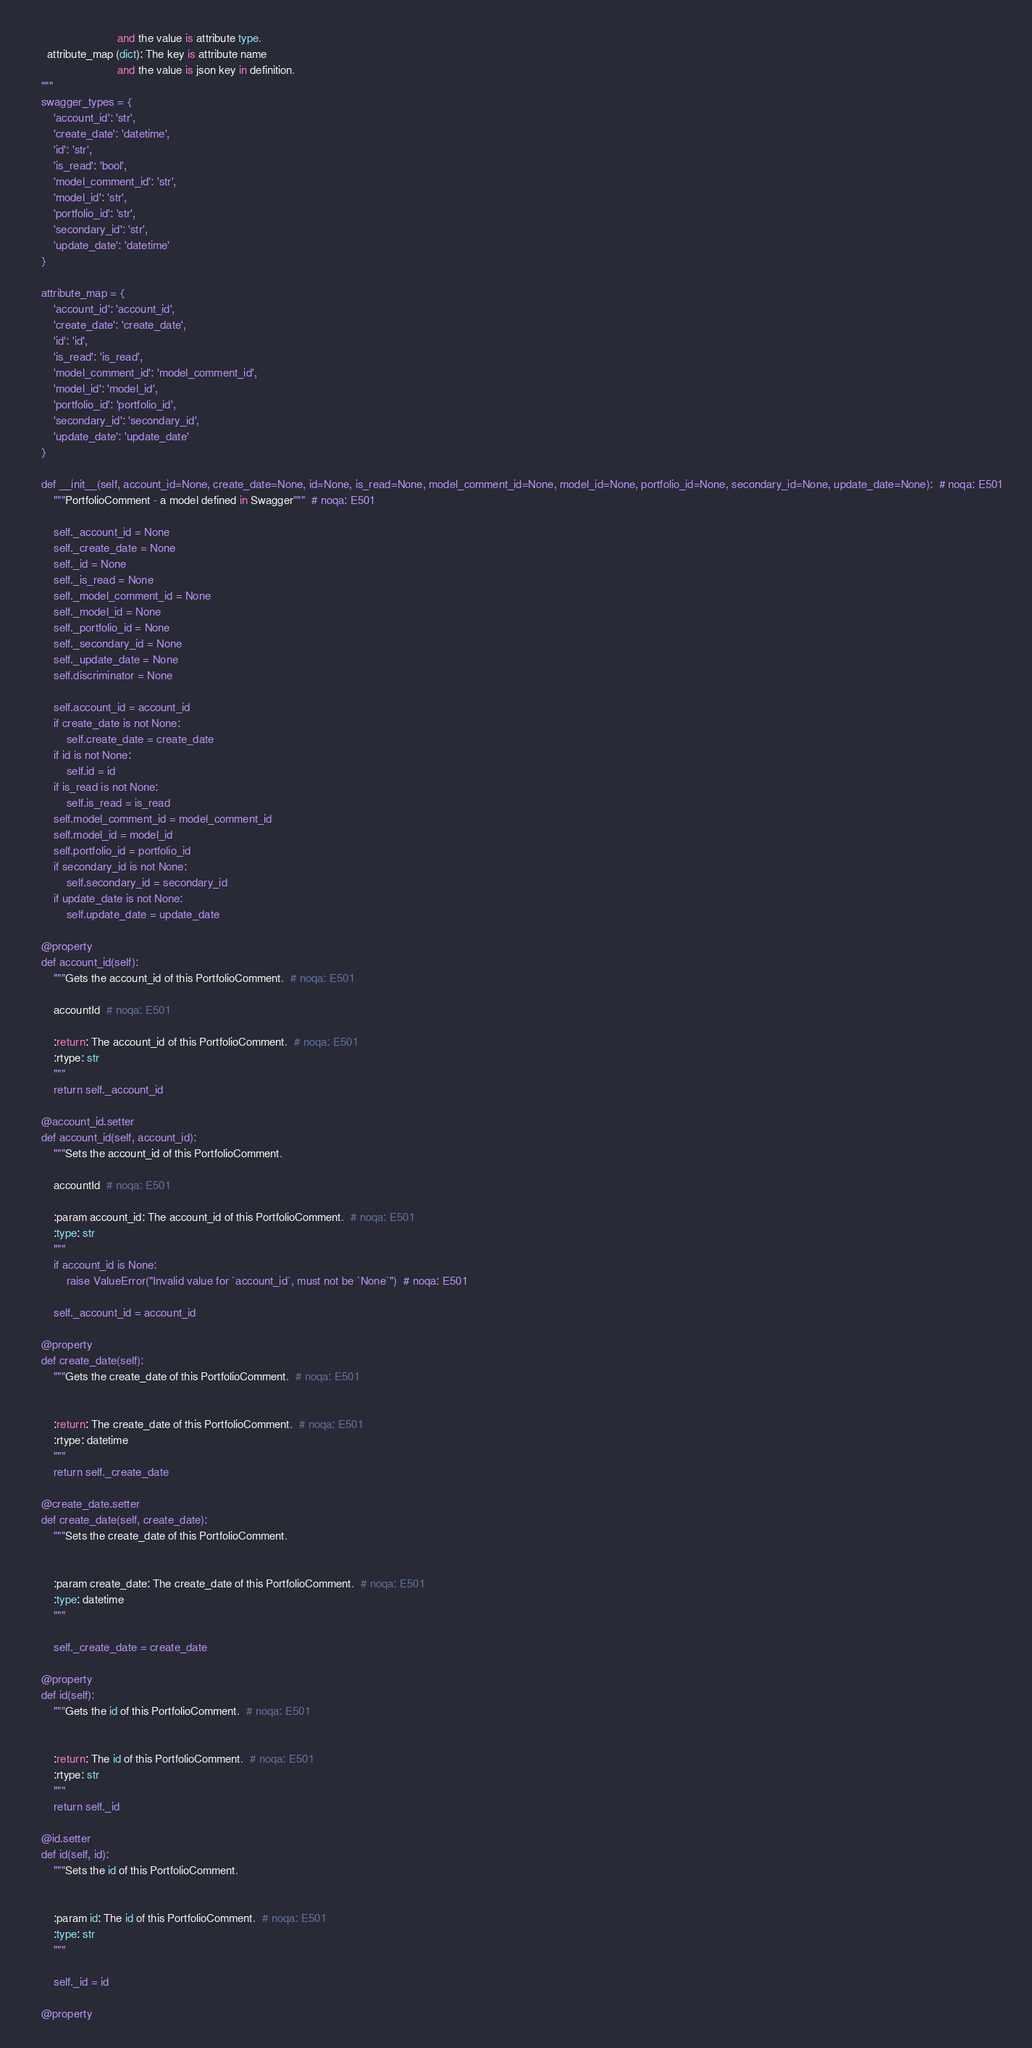Convert code to text. <code><loc_0><loc_0><loc_500><loc_500><_Python_>                            and the value is attribute type.
      attribute_map (dict): The key is attribute name
                            and the value is json key in definition.
    """
    swagger_types = {
        'account_id': 'str',
        'create_date': 'datetime',
        'id': 'str',
        'is_read': 'bool',
        'model_comment_id': 'str',
        'model_id': 'str',
        'portfolio_id': 'str',
        'secondary_id': 'str',
        'update_date': 'datetime'
    }

    attribute_map = {
        'account_id': 'account_id',
        'create_date': 'create_date',
        'id': 'id',
        'is_read': 'is_read',
        'model_comment_id': 'model_comment_id',
        'model_id': 'model_id',
        'portfolio_id': 'portfolio_id',
        'secondary_id': 'secondary_id',
        'update_date': 'update_date'
    }

    def __init__(self, account_id=None, create_date=None, id=None, is_read=None, model_comment_id=None, model_id=None, portfolio_id=None, secondary_id=None, update_date=None):  # noqa: E501
        """PortfolioComment - a model defined in Swagger"""  # noqa: E501

        self._account_id = None
        self._create_date = None
        self._id = None
        self._is_read = None
        self._model_comment_id = None
        self._model_id = None
        self._portfolio_id = None
        self._secondary_id = None
        self._update_date = None
        self.discriminator = None

        self.account_id = account_id
        if create_date is not None:
            self.create_date = create_date
        if id is not None:
            self.id = id
        if is_read is not None:
            self.is_read = is_read
        self.model_comment_id = model_comment_id
        self.model_id = model_id
        self.portfolio_id = portfolio_id
        if secondary_id is not None:
            self.secondary_id = secondary_id
        if update_date is not None:
            self.update_date = update_date

    @property
    def account_id(self):
        """Gets the account_id of this PortfolioComment.  # noqa: E501

        accountId  # noqa: E501

        :return: The account_id of this PortfolioComment.  # noqa: E501
        :rtype: str
        """
        return self._account_id

    @account_id.setter
    def account_id(self, account_id):
        """Sets the account_id of this PortfolioComment.

        accountId  # noqa: E501

        :param account_id: The account_id of this PortfolioComment.  # noqa: E501
        :type: str
        """
        if account_id is None:
            raise ValueError("Invalid value for `account_id`, must not be `None`")  # noqa: E501

        self._account_id = account_id

    @property
    def create_date(self):
        """Gets the create_date of this PortfolioComment.  # noqa: E501


        :return: The create_date of this PortfolioComment.  # noqa: E501
        :rtype: datetime
        """
        return self._create_date

    @create_date.setter
    def create_date(self, create_date):
        """Sets the create_date of this PortfolioComment.


        :param create_date: The create_date of this PortfolioComment.  # noqa: E501
        :type: datetime
        """

        self._create_date = create_date

    @property
    def id(self):
        """Gets the id of this PortfolioComment.  # noqa: E501


        :return: The id of this PortfolioComment.  # noqa: E501
        :rtype: str
        """
        return self._id

    @id.setter
    def id(self, id):
        """Sets the id of this PortfolioComment.


        :param id: The id of this PortfolioComment.  # noqa: E501
        :type: str
        """

        self._id = id

    @property</code> 